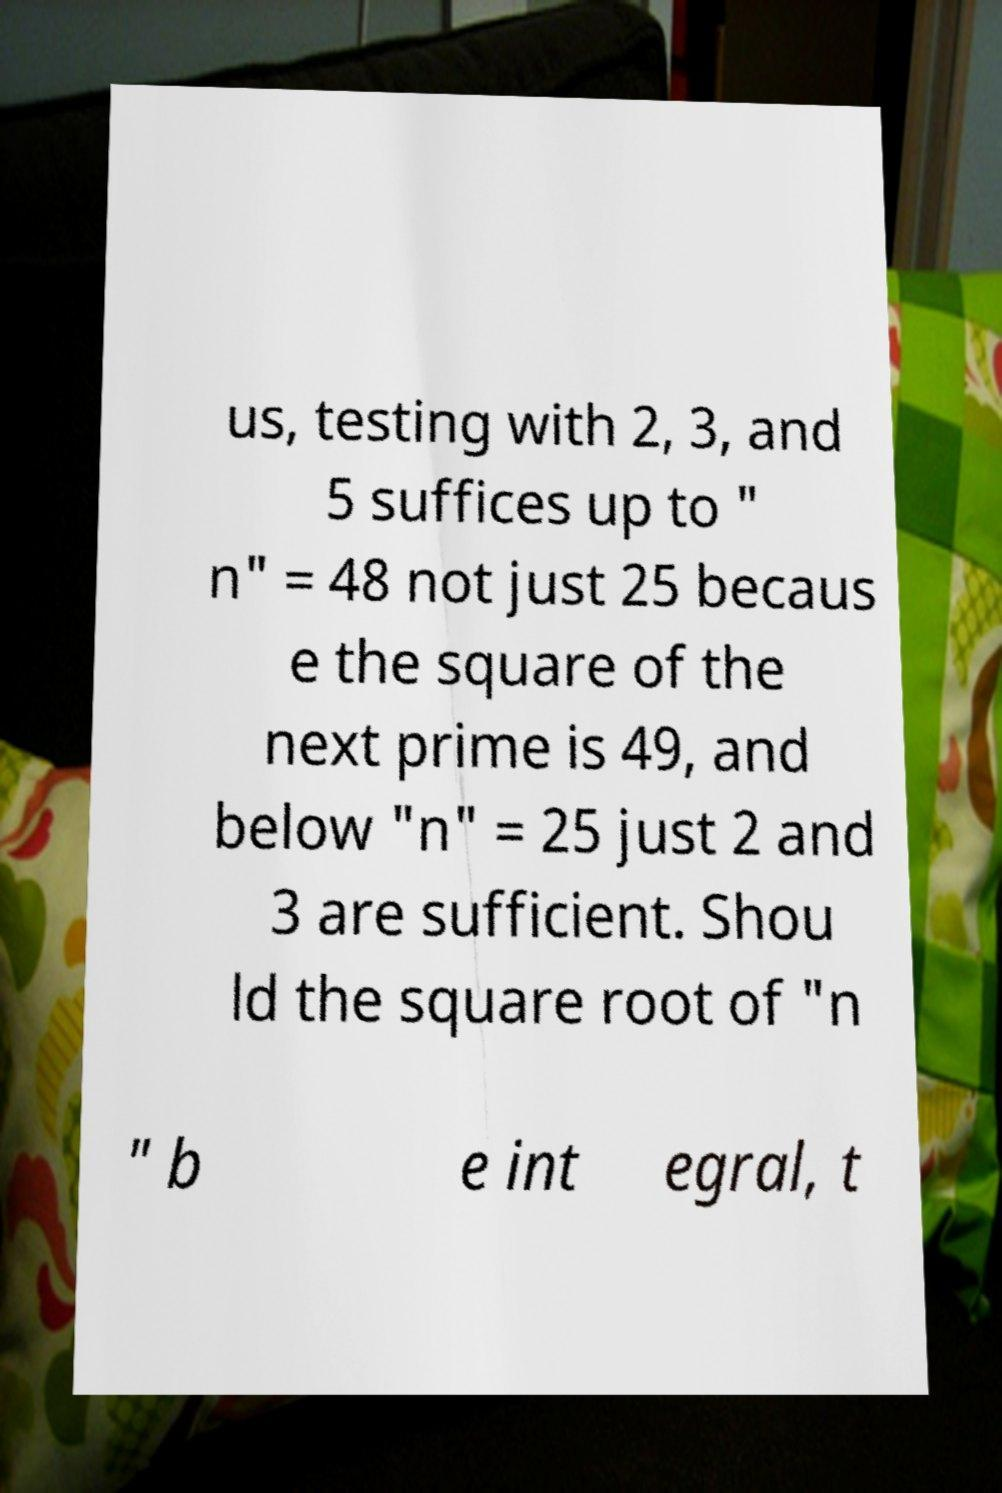For documentation purposes, I need the text within this image transcribed. Could you provide that? us, testing with 2, 3, and 5 suffices up to " n" = 48 not just 25 becaus e the square of the next prime is 49, and below "n" = 25 just 2 and 3 are sufficient. Shou ld the square root of "n " b e int egral, t 